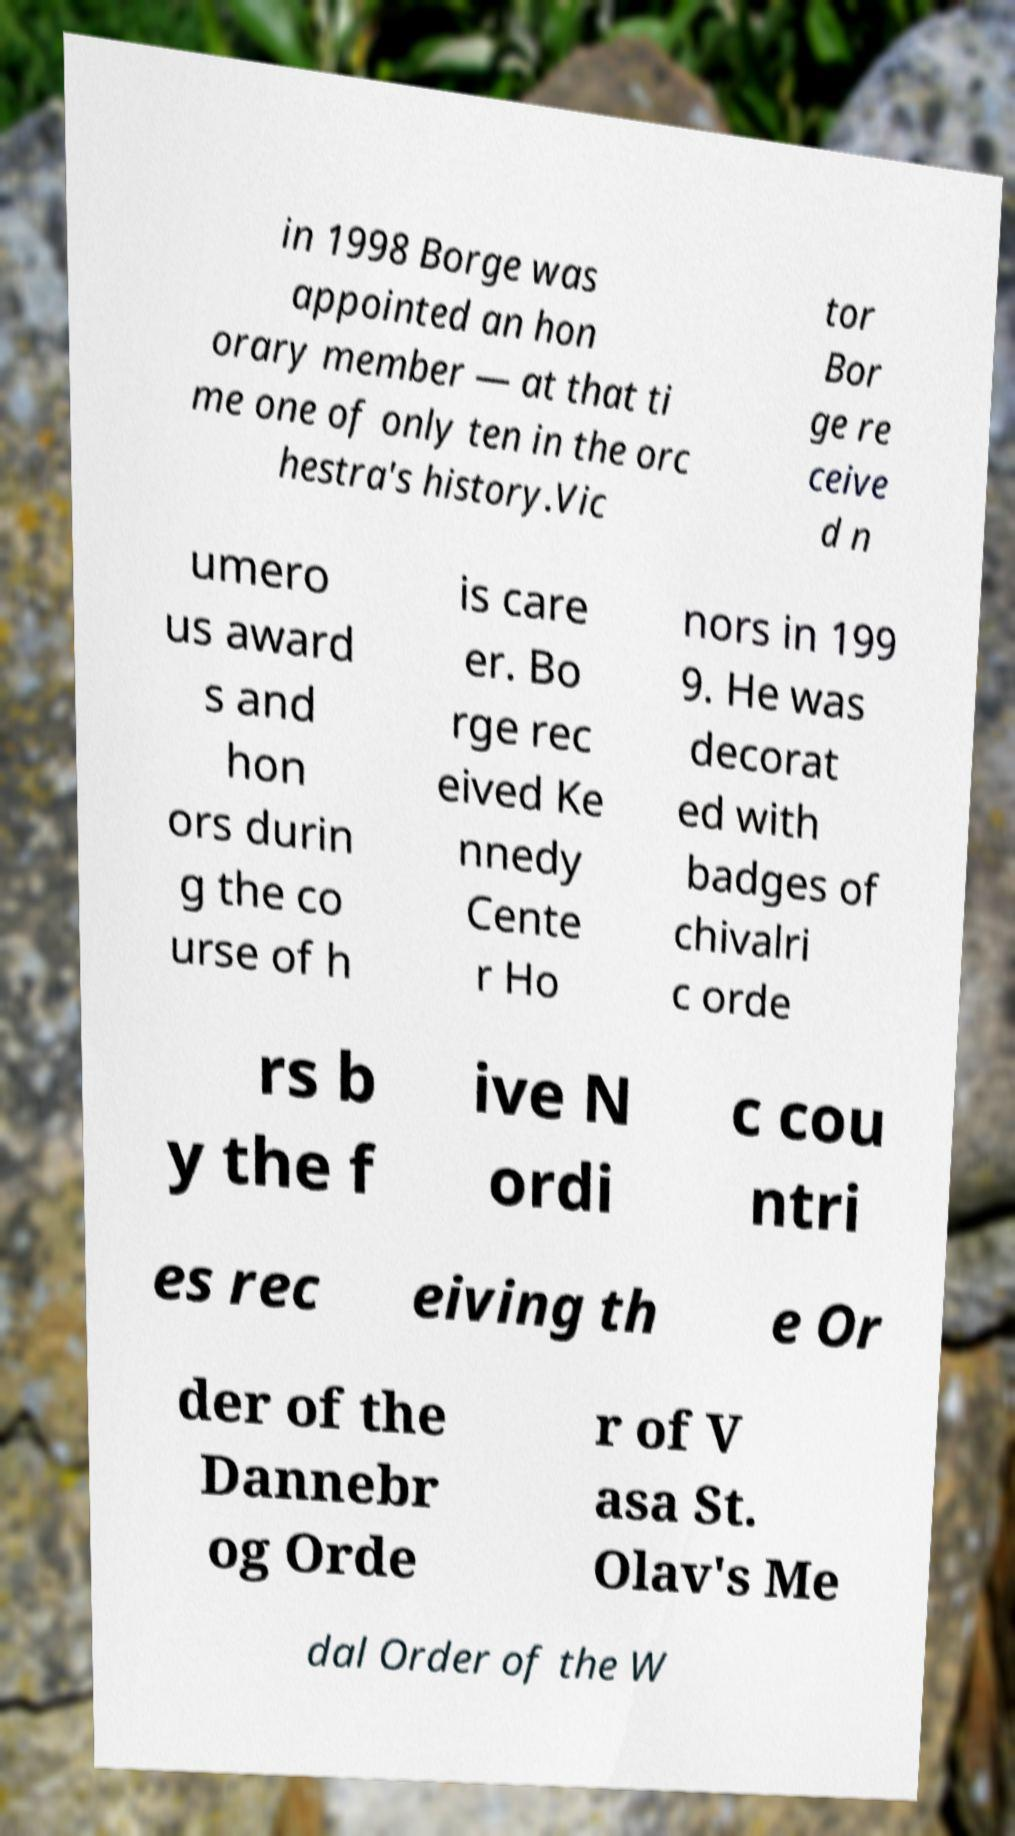Please identify and transcribe the text found in this image. in 1998 Borge was appointed an hon orary member — at that ti me one of only ten in the orc hestra's history.Vic tor Bor ge re ceive d n umero us award s and hon ors durin g the co urse of h is care er. Bo rge rec eived Ke nnedy Cente r Ho nors in 199 9. He was decorat ed with badges of chivalri c orde rs b y the f ive N ordi c cou ntri es rec eiving th e Or der of the Dannebr og Orde r of V asa St. Olav's Me dal Order of the W 